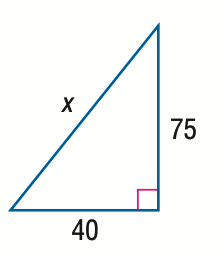Question: Find x.
Choices:
A. 80
B. 85
C. 90
D. 95
Answer with the letter. Answer: B 